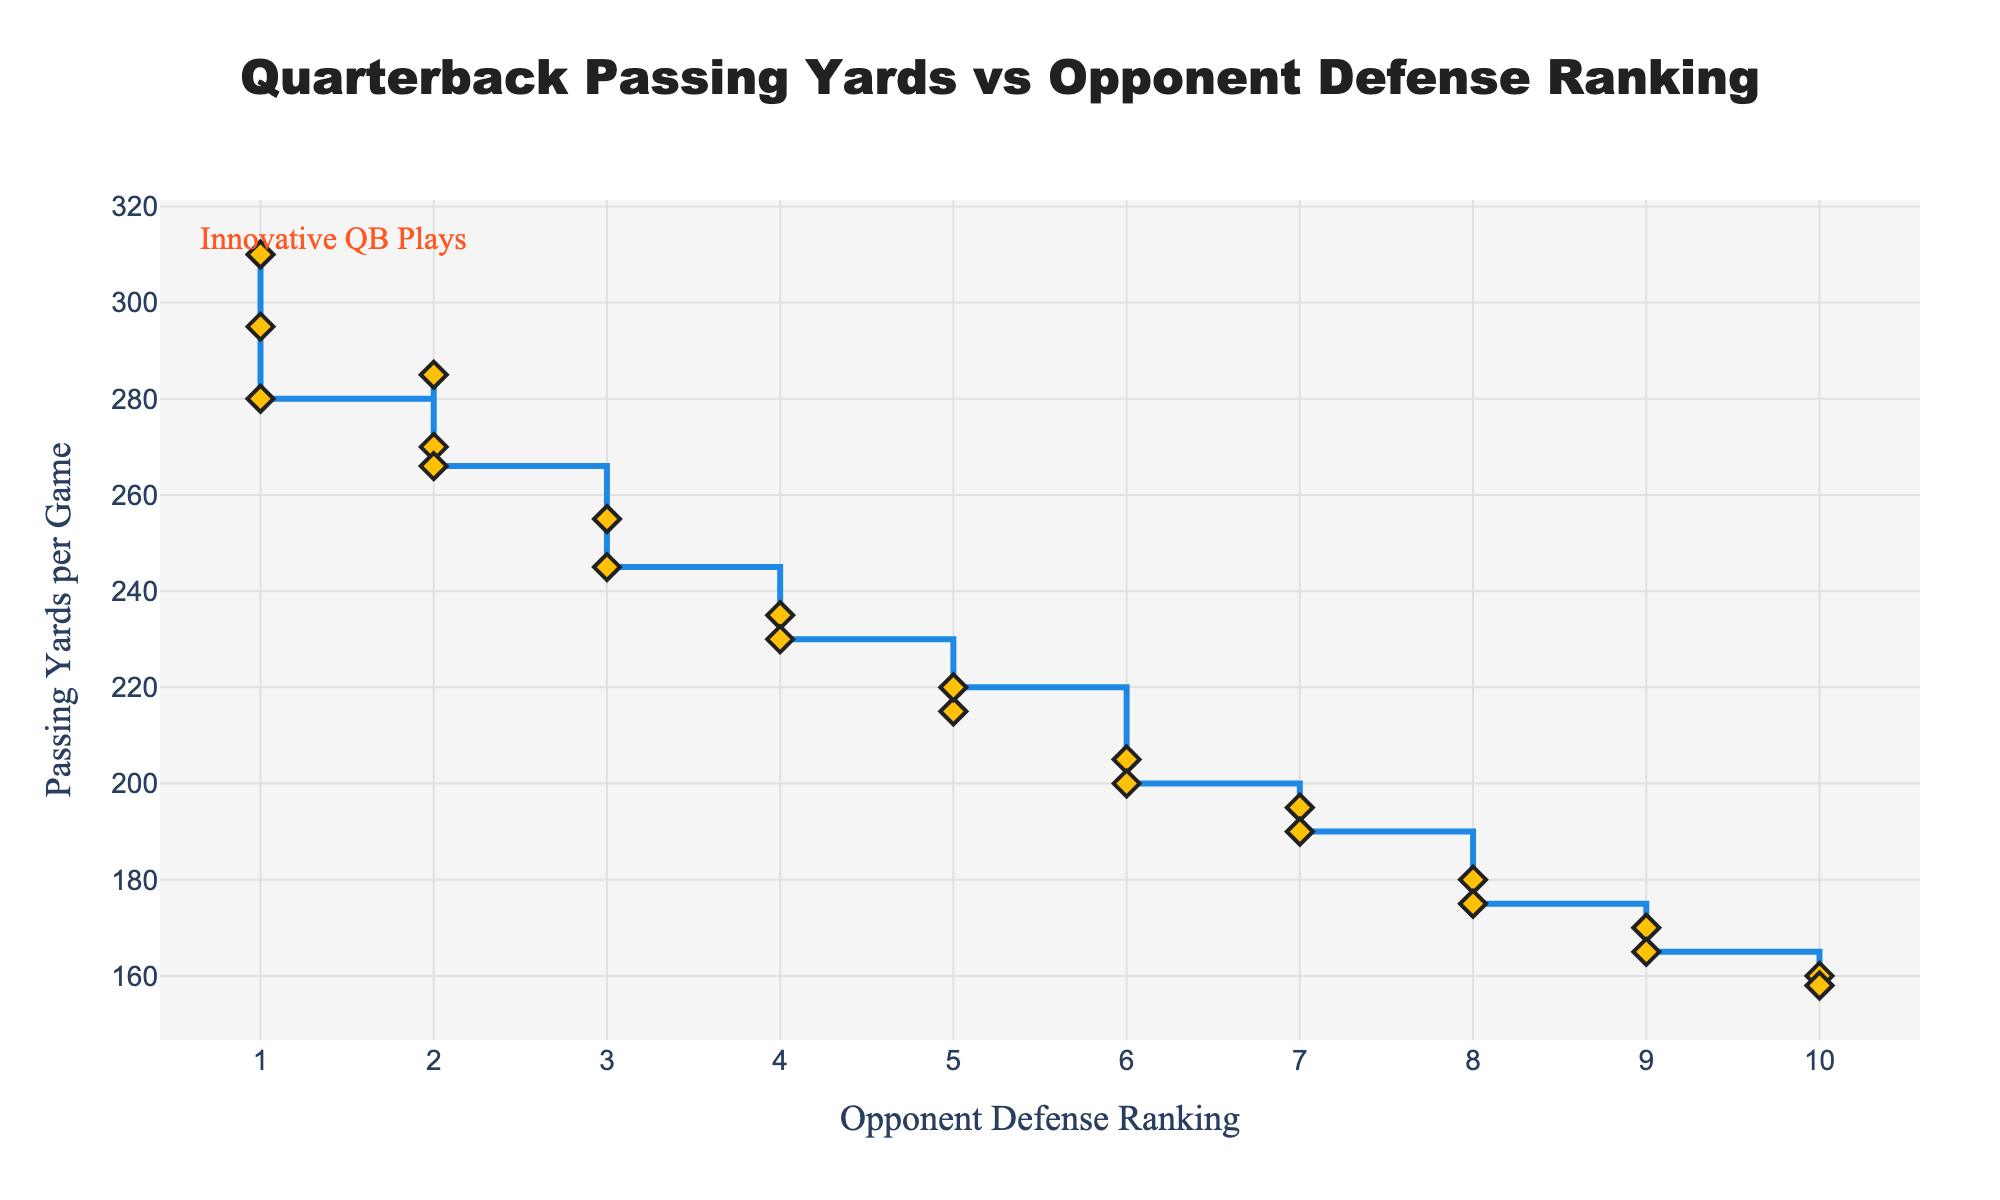What's the title of the figure? The title of the figure is usually located at the top center in larger fonts. It reads "Quarterback Passing Yards vs Opponent Defense Ranking".
Answer: Quarterback Passing Yards vs Opponent Defense Ranking What do the x-axis and y-axis represent? The x-axis title is "Opponent Defense Ranking" and the y-axis title is "Passing Yards per Game". These are typically given in a larger, bold font near the respective axes.
Answer: Opponent Defense Ranking, Passing Yards per Game How many data points are shown in the plot? Each opponent defense ranking from 1 to 10 has corresponding passing yards per game data points, indicated by diamond markers. Since there are rankings from 1 to 10 with two data points each, it totals 20 data points.
Answer: 20 Which opponent defense ranking corresponds to the highest passing yards per game? The plot shows the highest passing yards per game near the 1st-ranked opponent defense, visually the first step at the top of the y-axis. The exact value is 310 yards.
Answer: 1 What is the passing yards range observed in the plot? The highest value on the y-axis is 310 yards and the lowest value is 158 yards, visible through the vertical range of the markers.
Answer: 158 to 310 yards What is the general trend of passing yards as the opponent defense ranking increases? By observing the plot, you can see that the passing yards generally decrease as the opponent defense ranking increases, indicated by the descending steps.
Answer: Decreasing How does the passing yardage change between the 5th and 6th ranked opponent defenses? The passing yards per game drop from an average of around 217.5 yards (average of 220 and 215) at the 5th ranking to around 202.5 yards (average of 205 and 200) at the 6th ranking.
Answer: Drop by 15 yards Which opponent defense ranking shows the smallest variation in passing yards per game? The 9th-ranked opponent defense shows a very small variation, from 170 to 165 yards, indicated by a shorter step height compared to others.
Answer: 9 How many yards per game do you lose on average when moving from facing a 3rd to a 4th ranked defense? The average passing yards for a 3rd ranked defense is around 250 (average of 255 and 245), and for a 4th ranked defense it's around 232.5 (average of 235 and 230), resulting in an average loss of 17.5 yards.
Answer: 17.5 yards Which ranked defenses make the biggest difference in passing yards in this plot? The biggest drop is from the 1st to the 2nd ranked defenses, where the drop from an average of 295 yards (310 and 280) to 273.5 yards (285 and 266), resulting in a drop of 21.5 yards.
Answer: From 1st to 2nd ranking 